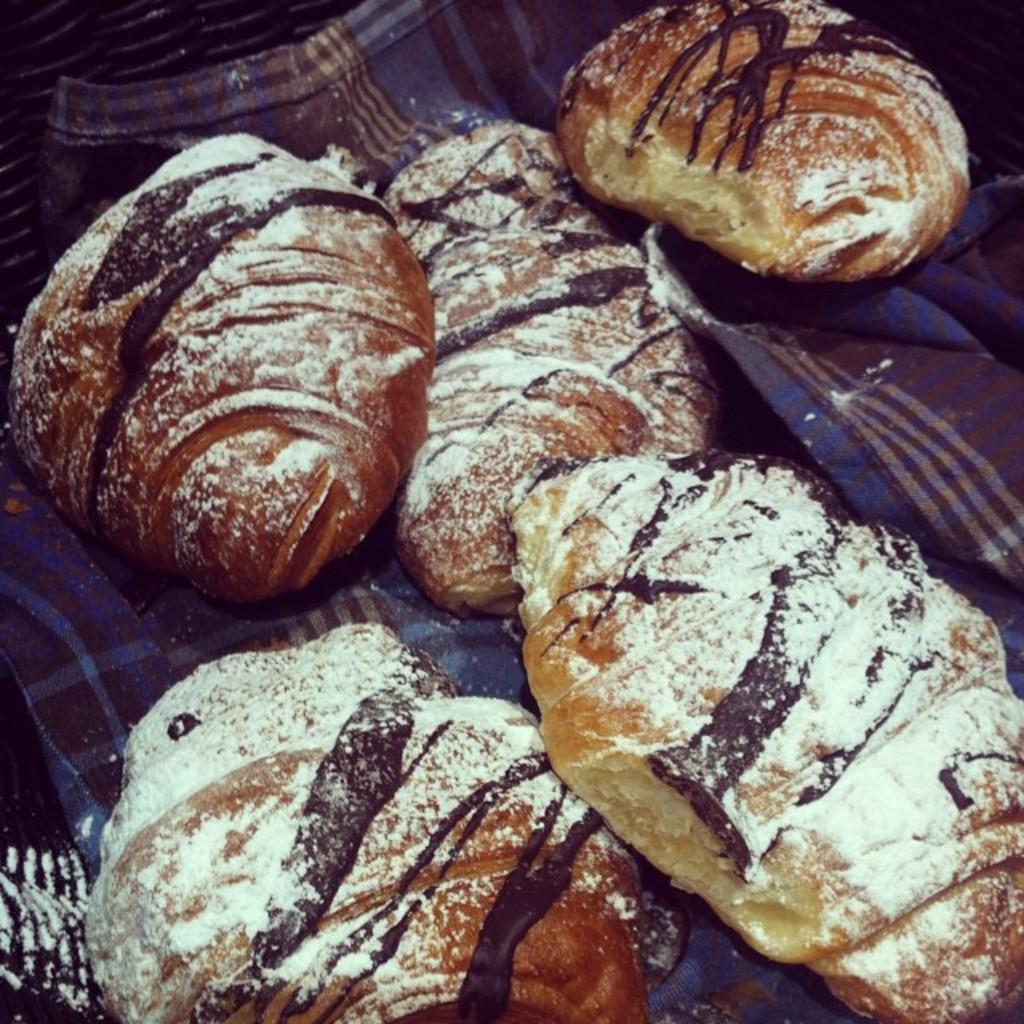What type of food can be seen on the surface in the image? There are sourdoughs on a surface in the image. Can you describe the surface on which the sourdoughs are placed? The surface resembles a cloth. What is the color and location of the object in the top left corner of the image? There is a black object in the top left corner of the image. How many bushes are visible in the image? There are no bushes visible in the image. What type of knowledge is being shared in the image? There is no indication of knowledge being shared in the image. 